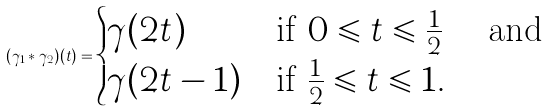<formula> <loc_0><loc_0><loc_500><loc_500>( \gamma _ { 1 } \ast \gamma _ { 2 } ) ( t ) = \begin{cases} \gamma ( 2 t ) & \text {if $0\leqslant t\leqslant \frac{1}{2}$ \quad and} \\ \gamma ( 2 t - 1 ) & \text {if $\frac{1}{2}\leqslant t\leqslant 1.$} \end{cases}</formula> 